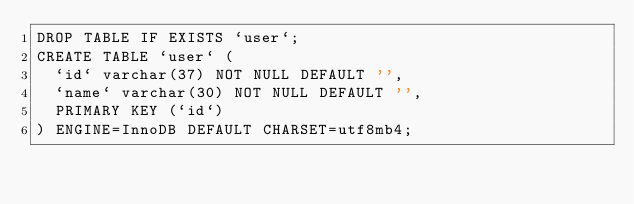<code> <loc_0><loc_0><loc_500><loc_500><_SQL_>DROP TABLE IF EXISTS `user`;
CREATE TABLE `user` (
  `id` varchar(37) NOT NULL DEFAULT '',
  `name` varchar(30) NOT NULL DEFAULT '',
  PRIMARY KEY (`id`)
) ENGINE=InnoDB DEFAULT CHARSET=utf8mb4;
</code> 